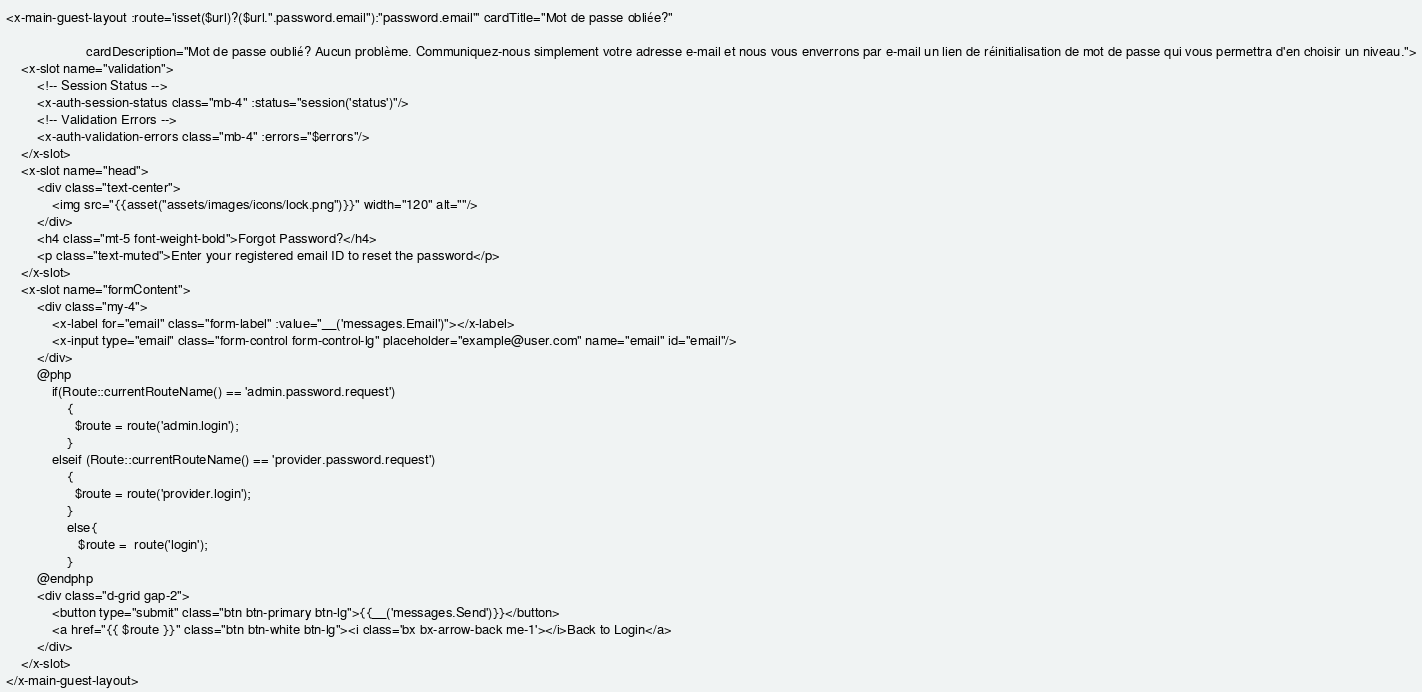Convert code to text. <code><loc_0><loc_0><loc_500><loc_500><_PHP_><x-main-guest-layout :route='isset($url)?($url.".password.email"):"password.email"' cardTitle="Mot de passe obliée?"

                     cardDescription="Mot de passe oublié? Aucun problème. Communiquez-nous simplement votre adresse e-mail et nous vous enverrons par e-mail un lien de réinitialisation de mot de passe qui vous permettra d'en choisir un niveau.">
    <x-slot name="validation">
        <!-- Session Status -->
        <x-auth-session-status class="mb-4" :status="session('status')"/>
        <!-- Validation Errors -->
        <x-auth-validation-errors class="mb-4" :errors="$errors"/>
    </x-slot>
    <x-slot name="head">
        <div class="text-center">
            <img src="{{asset("assets/images/icons/lock.png")}}" width="120" alt=""/>
        </div>
        <h4 class="mt-5 font-weight-bold">Forgot Password?</h4>
        <p class="text-muted">Enter your registered email ID to reset the password</p>
    </x-slot>
    <x-slot name="formContent">
        <div class="my-4">
            <x-label for="email" class="form-label" :value="__('messages.Email')"></x-label>
            <x-input type="email" class="form-control form-control-lg" placeholder="example@user.com" name="email" id="email"/>
        </div>
        @php
            if(Route::currentRouteName() == 'admin.password.request')
                {
                  $route = route('admin.login');
                }
            elseif (Route::currentRouteName() == 'provider.password.request')
                {
                  $route = route('provider.login');
                }
                else{
                   $route =  route('login');
                }
        @endphp
        <div class="d-grid gap-2">
            <button type="submit" class="btn btn-primary btn-lg">{{__('messages.Send')}}</button>
            <a href="{{ $route }}" class="btn btn-white btn-lg"><i class='bx bx-arrow-back me-1'></i>Back to Login</a>
        </div>
    </x-slot>
</x-main-guest-layout>
</code> 